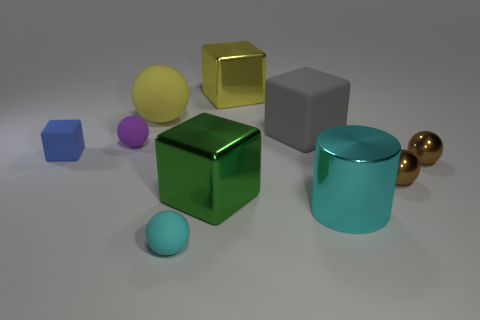There is a thing that is in front of the cyan thing that is on the right side of the large yellow metallic block; what size is it?
Keep it short and to the point. Small. Is the color of the large ball the same as the shiny cylinder?
Provide a succinct answer. No. How many matte objects are either big cyan objects or tiny things?
Offer a very short reply. 3. What number of tiny green metal spheres are there?
Your answer should be compact. 0. Is the big yellow thing to the left of the big green metallic block made of the same material as the object behind the big rubber ball?
Offer a very short reply. No. The other small thing that is the same shape as the yellow shiny object is what color?
Offer a terse response. Blue. What material is the block on the right side of the large metallic thing that is behind the green thing?
Provide a short and direct response. Rubber. Does the large yellow shiny object that is behind the tiny cyan matte thing have the same shape as the large metallic object right of the big yellow shiny block?
Make the answer very short. No. How big is the rubber object that is both in front of the purple matte sphere and left of the big yellow rubber thing?
Offer a terse response. Small. What number of other objects are the same color as the large cylinder?
Your answer should be very brief. 1. 